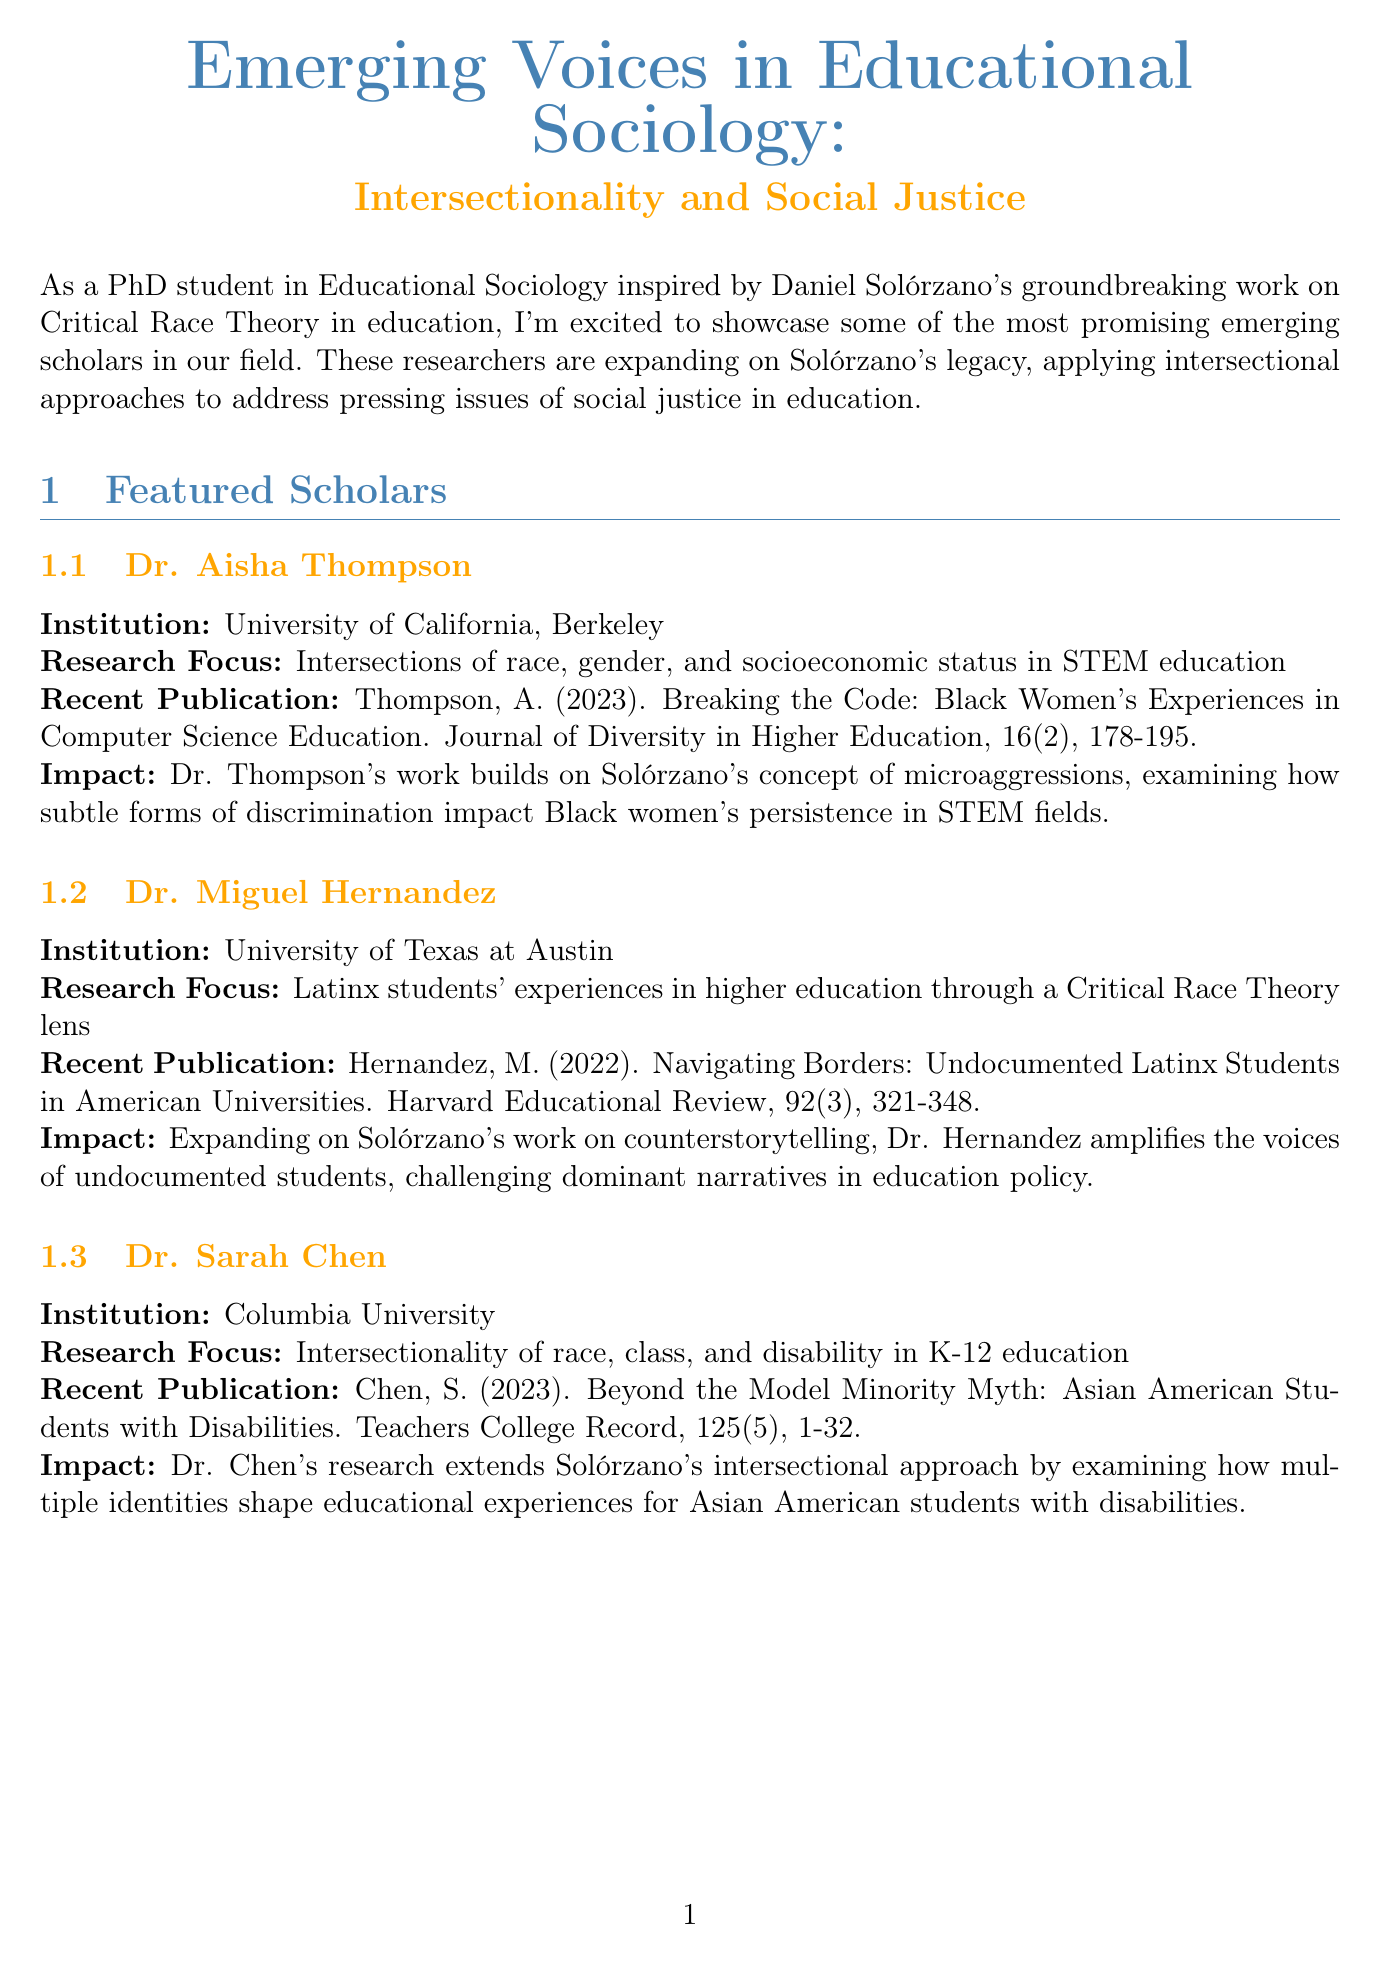What is the title of the newsletter? The title of the newsletter is explicitly stated at the beginning of the document.
Answer: Emerging Voices in Educational Sociology: Intersectionality and Social Justice Who is the keynote speaker at the upcoming conference? The keynote speaker is listed in the section about the upcoming conference.
Answer: Dr. Kimberlé Crenshaw What is Dr. Aisha Thompson's research focus? The research focus for Dr. Thompson is provided in her featured scholar section.
Answer: Intersections of race, gender, and socioeconomic status in STEM education When is the deadline for the call for papers? The deadline for submissions is mentioned in the call for papers section.
Answer: December 1, 2023 What university is Dr. Miguel Hernandez affiliated with? Dr. Hernandez's institution is listed in his profile within the featured scholars section.
Answer: University of Texas at Austin What theme is the special issue of the journal focused on? The theme of the special issue is specifically mentioned in the call for papers section.
Answer: Intersectional Approaches to Educational Equity in a Post-Pandemic World Which publication features Dr. Sarah Chen's recent research? The recent publication for Dr. Chen is clearly stated in her profile.
Answer: Teachers College Record What years were the recommended readings published? The publication years for the recommended readings can be found listed alongside their descriptions.
Answer: 2021 What type of research approaches do the featured scholars apply? The research approaches are indirectly suggested through their research focuses and impacts.
Answer: Intersectional approaches 